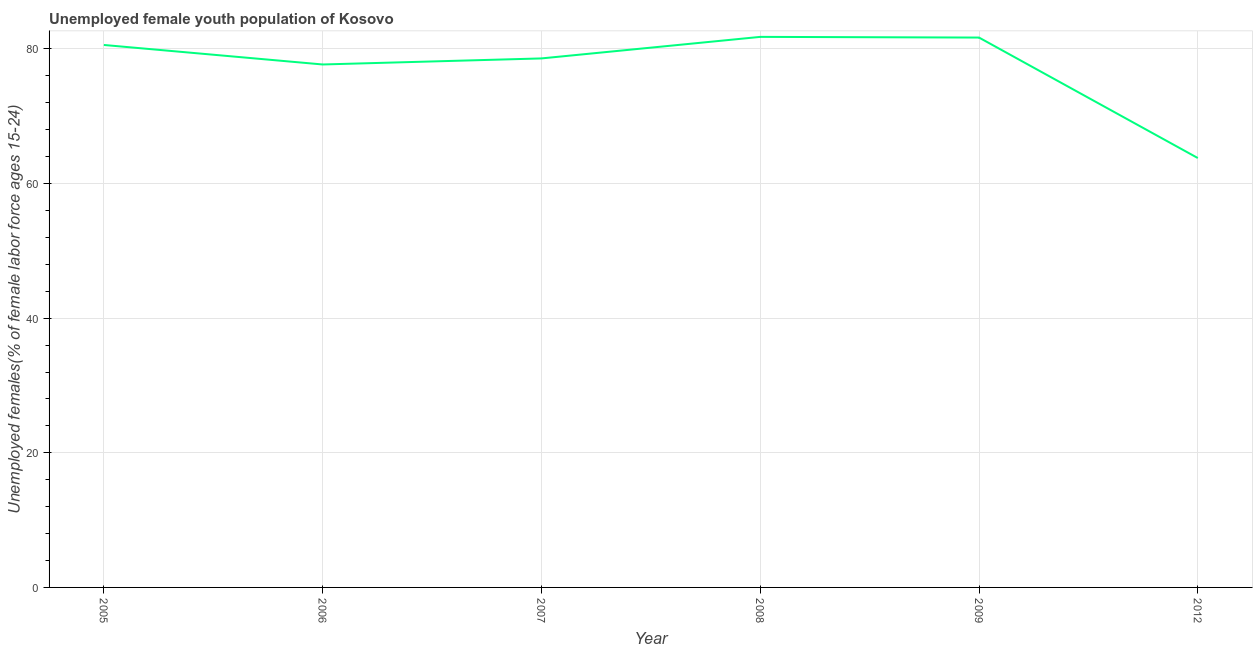What is the unemployed female youth in 2009?
Make the answer very short. 81.7. Across all years, what is the maximum unemployed female youth?
Your answer should be compact. 81.8. Across all years, what is the minimum unemployed female youth?
Provide a short and direct response. 63.8. In which year was the unemployed female youth maximum?
Your response must be concise. 2008. In which year was the unemployed female youth minimum?
Provide a succinct answer. 2012. What is the sum of the unemployed female youth?
Your answer should be compact. 464.2. What is the difference between the unemployed female youth in 2006 and 2008?
Provide a short and direct response. -4.1. What is the average unemployed female youth per year?
Provide a short and direct response. 77.37. What is the median unemployed female youth?
Provide a short and direct response. 79.6. In how many years, is the unemployed female youth greater than 4 %?
Your response must be concise. 6. Do a majority of the years between 2009 and 2006 (inclusive) have unemployed female youth greater than 68 %?
Provide a succinct answer. Yes. What is the ratio of the unemployed female youth in 2007 to that in 2009?
Ensure brevity in your answer.  0.96. Is the unemployed female youth in 2005 less than that in 2012?
Give a very brief answer. No. Is the difference between the unemployed female youth in 2007 and 2008 greater than the difference between any two years?
Keep it short and to the point. No. What is the difference between the highest and the second highest unemployed female youth?
Keep it short and to the point. 0.1. Is the sum of the unemployed female youth in 2005 and 2007 greater than the maximum unemployed female youth across all years?
Ensure brevity in your answer.  Yes. What is the difference between the highest and the lowest unemployed female youth?
Make the answer very short. 18. In how many years, is the unemployed female youth greater than the average unemployed female youth taken over all years?
Your answer should be compact. 5. Does the unemployed female youth monotonically increase over the years?
Give a very brief answer. No. How many lines are there?
Provide a succinct answer. 1. How many years are there in the graph?
Provide a succinct answer. 6. What is the difference between two consecutive major ticks on the Y-axis?
Offer a terse response. 20. What is the title of the graph?
Make the answer very short. Unemployed female youth population of Kosovo. What is the label or title of the Y-axis?
Your answer should be very brief. Unemployed females(% of female labor force ages 15-24). What is the Unemployed females(% of female labor force ages 15-24) in 2005?
Your answer should be compact. 80.6. What is the Unemployed females(% of female labor force ages 15-24) in 2006?
Offer a terse response. 77.7. What is the Unemployed females(% of female labor force ages 15-24) in 2007?
Offer a terse response. 78.6. What is the Unemployed females(% of female labor force ages 15-24) in 2008?
Offer a terse response. 81.8. What is the Unemployed females(% of female labor force ages 15-24) of 2009?
Make the answer very short. 81.7. What is the Unemployed females(% of female labor force ages 15-24) in 2012?
Your answer should be very brief. 63.8. What is the difference between the Unemployed females(% of female labor force ages 15-24) in 2005 and 2006?
Offer a terse response. 2.9. What is the difference between the Unemployed females(% of female labor force ages 15-24) in 2006 and 2007?
Keep it short and to the point. -0.9. What is the difference between the Unemployed females(% of female labor force ages 15-24) in 2006 and 2008?
Make the answer very short. -4.1. What is the difference between the Unemployed females(% of female labor force ages 15-24) in 2006 and 2009?
Provide a succinct answer. -4. What is the difference between the Unemployed females(% of female labor force ages 15-24) in 2007 and 2009?
Provide a short and direct response. -3.1. What is the difference between the Unemployed females(% of female labor force ages 15-24) in 2008 and 2009?
Your answer should be very brief. 0.1. What is the difference between the Unemployed females(% of female labor force ages 15-24) in 2008 and 2012?
Ensure brevity in your answer.  18. What is the difference between the Unemployed females(% of female labor force ages 15-24) in 2009 and 2012?
Your answer should be very brief. 17.9. What is the ratio of the Unemployed females(% of female labor force ages 15-24) in 2005 to that in 2008?
Provide a succinct answer. 0.98. What is the ratio of the Unemployed females(% of female labor force ages 15-24) in 2005 to that in 2012?
Give a very brief answer. 1.26. What is the ratio of the Unemployed females(% of female labor force ages 15-24) in 2006 to that in 2009?
Your answer should be compact. 0.95. What is the ratio of the Unemployed females(% of female labor force ages 15-24) in 2006 to that in 2012?
Offer a terse response. 1.22. What is the ratio of the Unemployed females(% of female labor force ages 15-24) in 2007 to that in 2008?
Offer a very short reply. 0.96. What is the ratio of the Unemployed females(% of female labor force ages 15-24) in 2007 to that in 2012?
Your response must be concise. 1.23. What is the ratio of the Unemployed females(% of female labor force ages 15-24) in 2008 to that in 2009?
Provide a succinct answer. 1. What is the ratio of the Unemployed females(% of female labor force ages 15-24) in 2008 to that in 2012?
Give a very brief answer. 1.28. What is the ratio of the Unemployed females(% of female labor force ages 15-24) in 2009 to that in 2012?
Give a very brief answer. 1.28. 